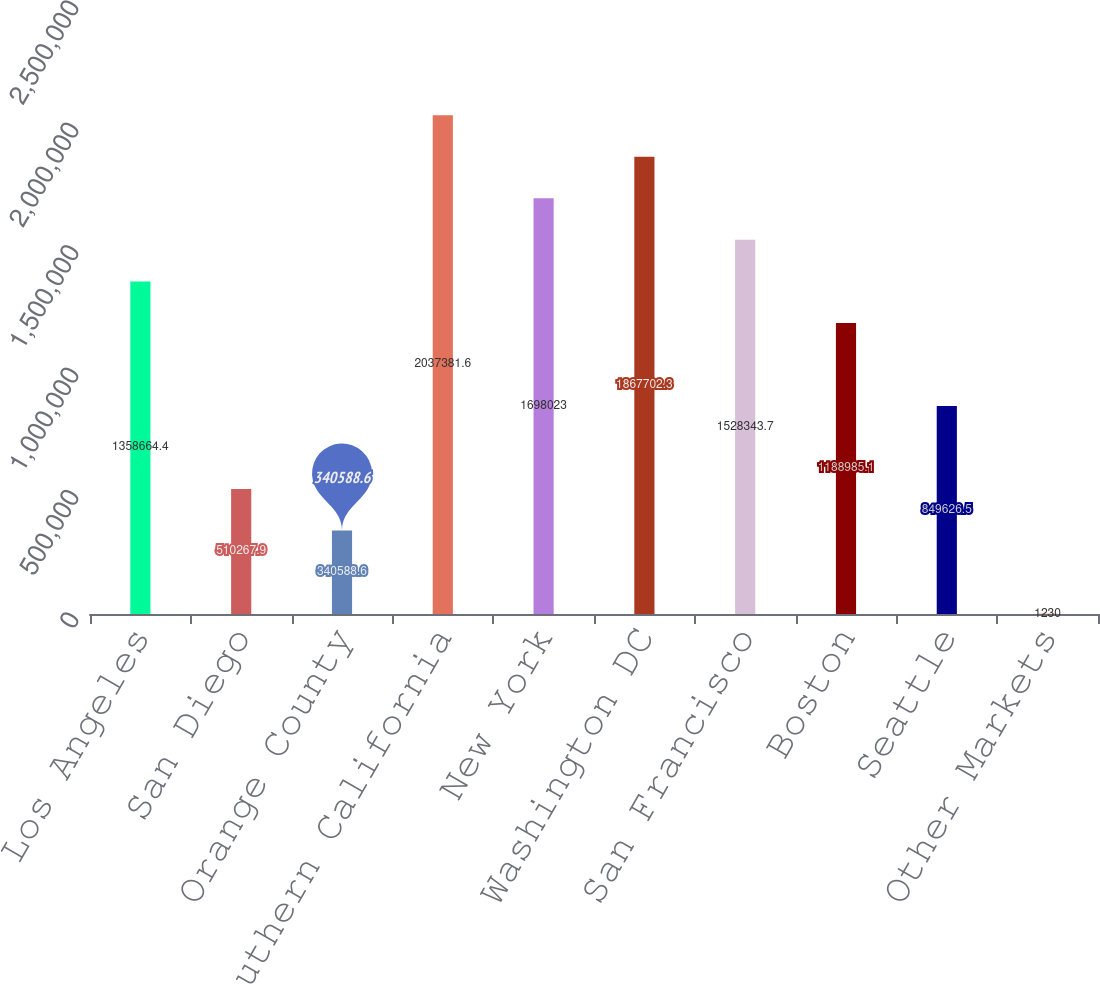Convert chart. <chart><loc_0><loc_0><loc_500><loc_500><bar_chart><fcel>Los Angeles<fcel>San Diego<fcel>Orange County<fcel>Subtotal - Southern California<fcel>New York<fcel>Washington DC<fcel>San Francisco<fcel>Boston<fcel>Seattle<fcel>Other Markets<nl><fcel>1.35866e+06<fcel>510268<fcel>340589<fcel>2.03738e+06<fcel>1.69802e+06<fcel>1.8677e+06<fcel>1.52834e+06<fcel>1.18899e+06<fcel>849626<fcel>1230<nl></chart> 